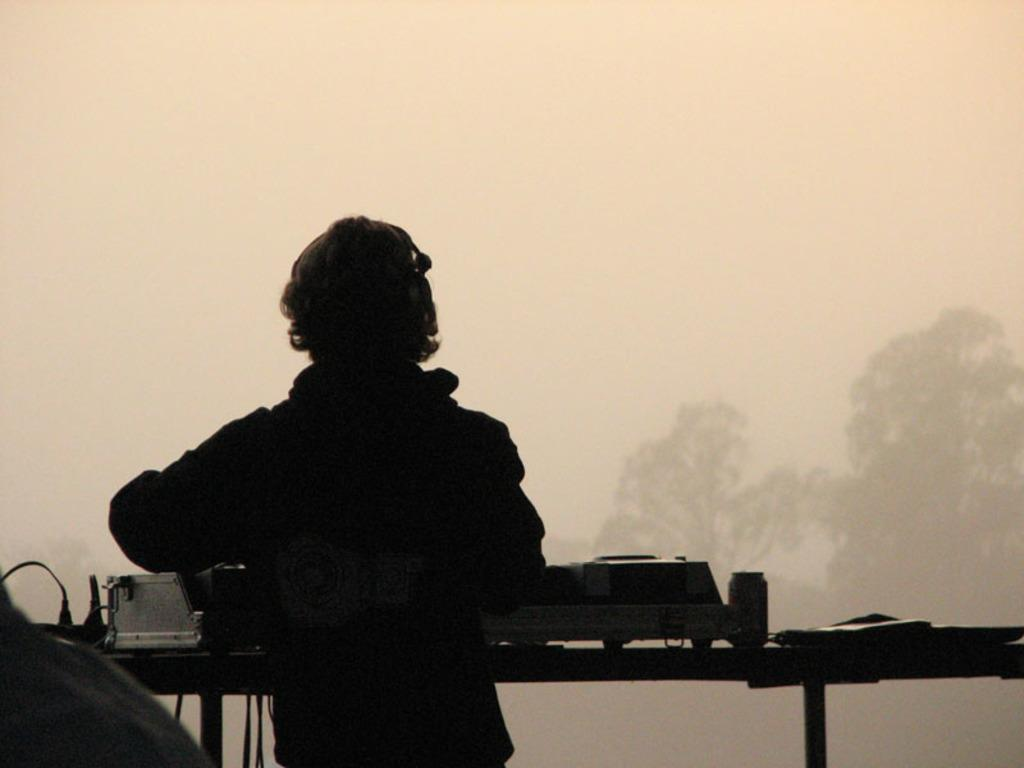What is the person in the image wearing? The person in the image is wearing a dress. What is located in front of the person? There is an object in front of the person. What can be seen in the background of the image? There are trees and the sky visible in the background of the image. What type of books is the person reading in the image? There are no books present in the image, so it is not possible to determine what type of books the person might be reading. 